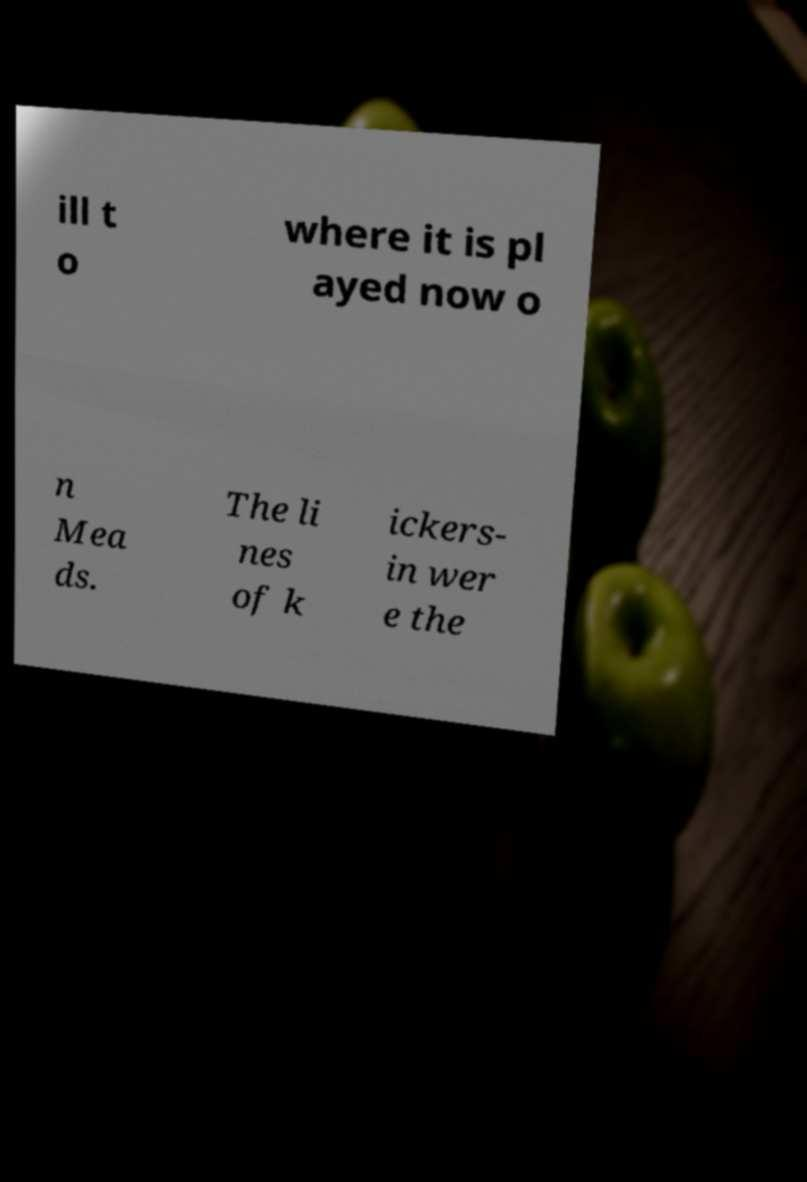Please read and relay the text visible in this image. What does it say? ill t o where it is pl ayed now o n Mea ds. The li nes of k ickers- in wer e the 